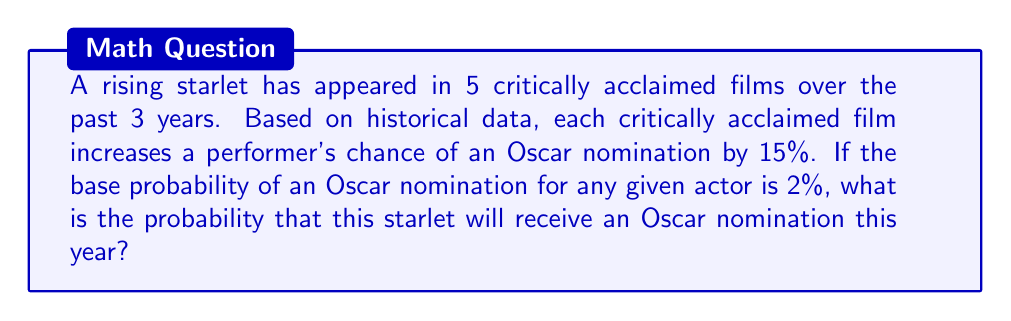Can you solve this math problem? Let's approach this step-by-step:

1) First, we need to calculate the total increase in probability due to the starlet's critically acclaimed films:
   $5 \text{ films} \times 15\% = 75\%$ increase

2) Now, we need to add this to the base probability:
   $2\% + 75\% = 77\%$

3) However, we can't simply use 77% as our final probability, as probabilities cannot exceed 100%. We need to use a method that asymptotically approaches 100% as we add more critically acclaimed films.

4) One way to do this is to consider the probability of not getting nominated, and how it decreases with each film. The probability of not getting nominated initially is:
   $1 - 0.02 = 0.98$ or $98\%$

5) For each critically acclaimed film, this probability is reduced by 15%:
   $0.98 \times (1 - 0.15)^5 = 0.98 \times 0.85^5 \approx 0.4439$

6) Therefore, the probability of getting nominated is:
   $1 - 0.4439 = 0.5561$ or approximately $55.61\%$
Answer: $55.61\%$ 